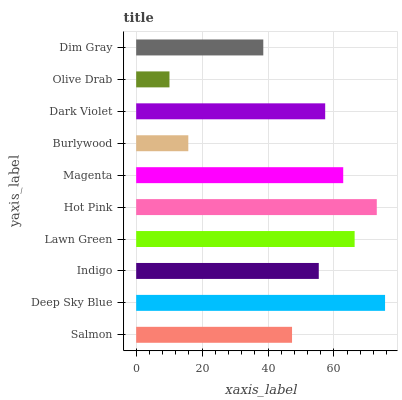Is Olive Drab the minimum?
Answer yes or no. Yes. Is Deep Sky Blue the maximum?
Answer yes or no. Yes. Is Indigo the minimum?
Answer yes or no. No. Is Indigo the maximum?
Answer yes or no. No. Is Deep Sky Blue greater than Indigo?
Answer yes or no. Yes. Is Indigo less than Deep Sky Blue?
Answer yes or no. Yes. Is Indigo greater than Deep Sky Blue?
Answer yes or no. No. Is Deep Sky Blue less than Indigo?
Answer yes or no. No. Is Dark Violet the high median?
Answer yes or no. Yes. Is Indigo the low median?
Answer yes or no. Yes. Is Dim Gray the high median?
Answer yes or no. No. Is Magenta the low median?
Answer yes or no. No. 